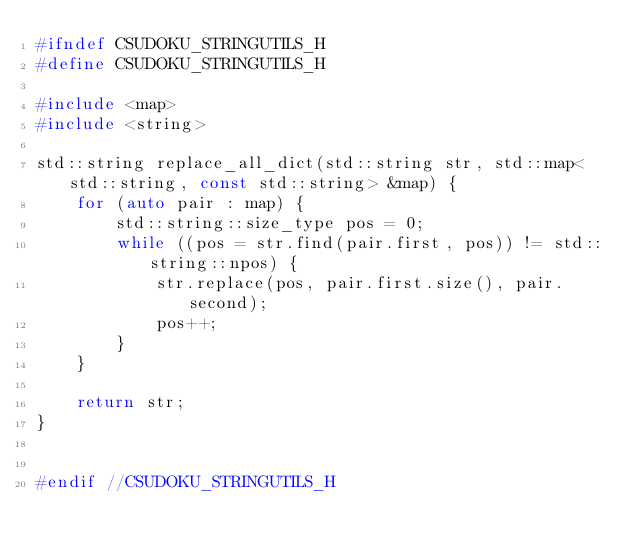<code> <loc_0><loc_0><loc_500><loc_500><_C_>#ifndef CSUDOKU_STRINGUTILS_H
#define CSUDOKU_STRINGUTILS_H

#include <map>
#include <string>

std::string replace_all_dict(std::string str, std::map<std::string, const std::string> &map) {
    for (auto pair : map) {
        std::string::size_type pos = 0;
        while ((pos = str.find(pair.first, pos)) != std::string::npos) {
            str.replace(pos, pair.first.size(), pair.second);
            pos++;
        }
    }

    return str;
}


#endif //CSUDOKU_STRINGUTILS_H
</code> 